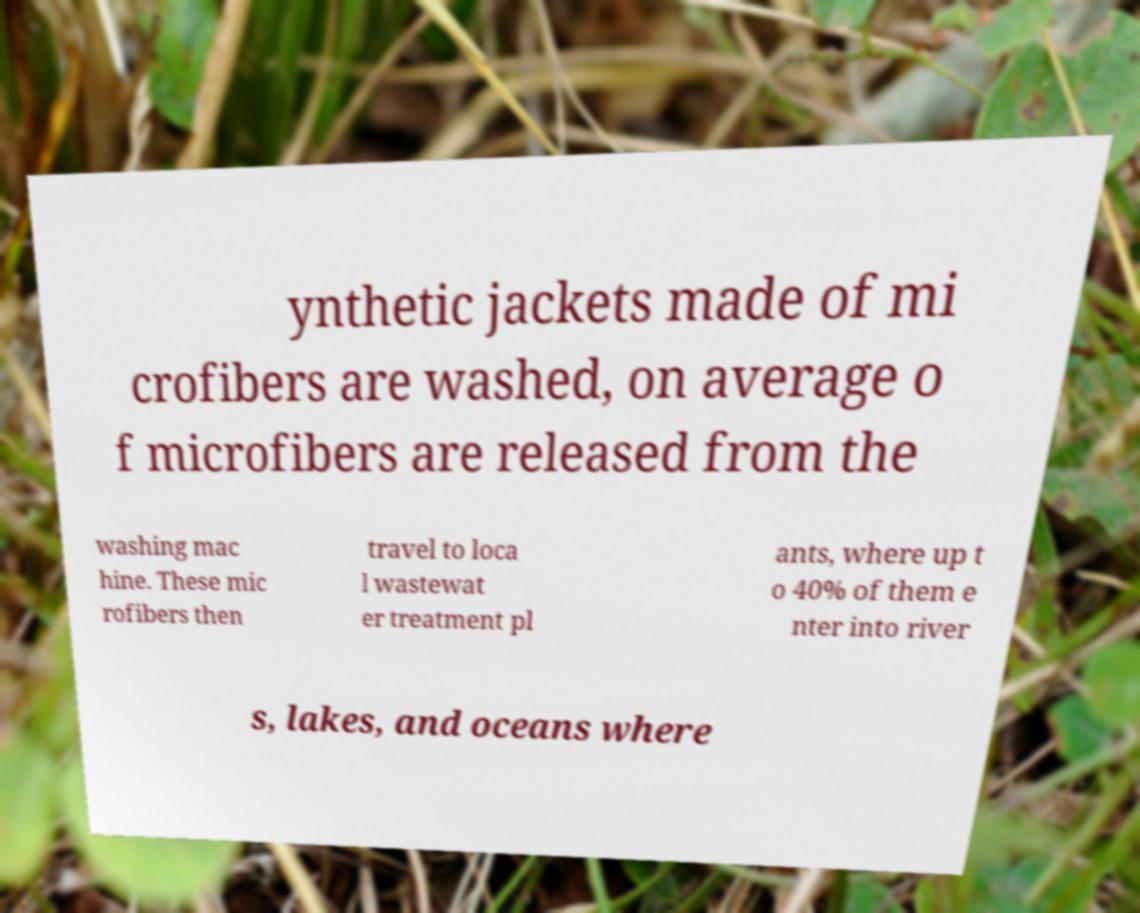Could you extract and type out the text from this image? ynthetic jackets made of mi crofibers are washed, on average o f microfibers are released from the washing mac hine. These mic rofibers then travel to loca l wastewat er treatment pl ants, where up t o 40% of them e nter into river s, lakes, and oceans where 